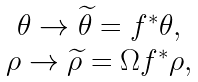Convert formula to latex. <formula><loc_0><loc_0><loc_500><loc_500>\begin{array} { c } \theta \to \widetilde { \theta } = f ^ { * } \theta , \\ \rho \to \widetilde { \rho } = \Omega f ^ { * } \rho , \end{array}</formula> 